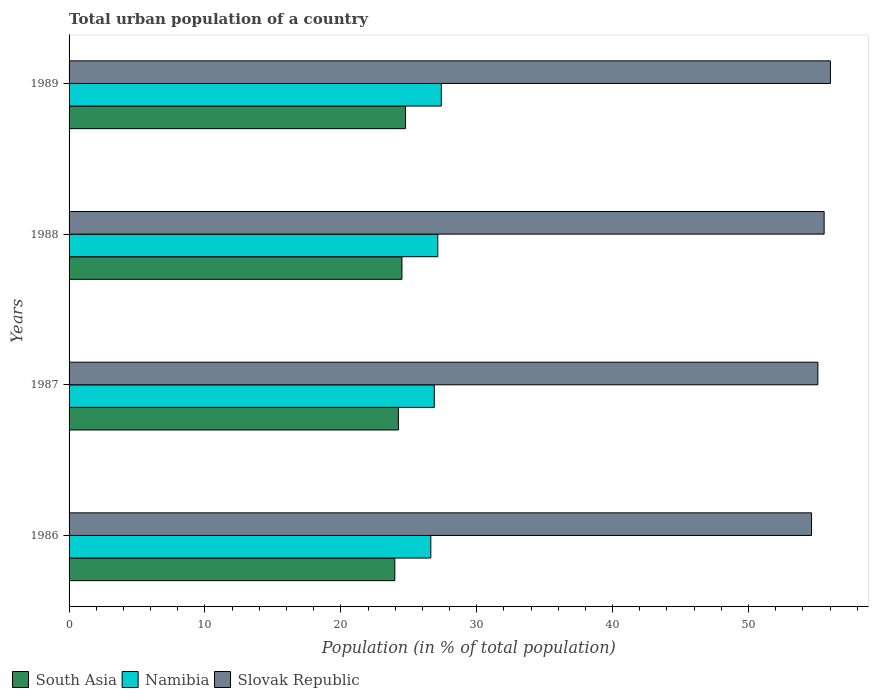How many groups of bars are there?
Keep it short and to the point. 4. Are the number of bars per tick equal to the number of legend labels?
Ensure brevity in your answer.  Yes. How many bars are there on the 1st tick from the top?
Provide a short and direct response. 3. What is the label of the 3rd group of bars from the top?
Keep it short and to the point. 1987. What is the urban population in Slovak Republic in 1986?
Offer a terse response. 54.64. Across all years, what is the maximum urban population in South Asia?
Give a very brief answer. 24.76. Across all years, what is the minimum urban population in South Asia?
Give a very brief answer. 23.97. In which year was the urban population in Namibia minimum?
Your response must be concise. 1986. What is the total urban population in Slovak Republic in the graph?
Your answer should be compact. 221.34. What is the difference between the urban population in South Asia in 1987 and that in 1989?
Keep it short and to the point. -0.53. What is the difference between the urban population in Slovak Republic in 1989 and the urban population in Namibia in 1986?
Offer a very short reply. 29.41. What is the average urban population in Slovak Republic per year?
Your answer should be very brief. 55.34. In the year 1987, what is the difference between the urban population in Slovak Republic and urban population in South Asia?
Your answer should be compact. 30.87. In how many years, is the urban population in South Asia greater than 42 %?
Provide a succinct answer. 0. What is the ratio of the urban population in Slovak Republic in 1986 to that in 1988?
Keep it short and to the point. 0.98. What is the difference between the highest and the second highest urban population in Slovak Republic?
Offer a very short reply. 0.46. What is the difference between the highest and the lowest urban population in South Asia?
Your answer should be compact. 0.79. What does the 2nd bar from the top in 1988 represents?
Your answer should be compact. Namibia. What does the 3rd bar from the bottom in 1988 represents?
Ensure brevity in your answer.  Slovak Republic. Is it the case that in every year, the sum of the urban population in South Asia and urban population in Slovak Republic is greater than the urban population in Namibia?
Give a very brief answer. Yes. How many bars are there?
Give a very brief answer. 12. Are all the bars in the graph horizontal?
Provide a short and direct response. Yes. How many years are there in the graph?
Ensure brevity in your answer.  4. Are the values on the major ticks of X-axis written in scientific E-notation?
Provide a succinct answer. No. Does the graph contain any zero values?
Keep it short and to the point. No. Does the graph contain grids?
Offer a terse response. No. Where does the legend appear in the graph?
Provide a short and direct response. Bottom left. How are the legend labels stacked?
Ensure brevity in your answer.  Horizontal. What is the title of the graph?
Your answer should be compact. Total urban population of a country. What is the label or title of the X-axis?
Offer a very short reply. Population (in % of total population). What is the Population (in % of total population) of South Asia in 1986?
Your answer should be very brief. 23.97. What is the Population (in % of total population) of Namibia in 1986?
Make the answer very short. 26.62. What is the Population (in % of total population) of Slovak Republic in 1986?
Your answer should be very brief. 54.64. What is the Population (in % of total population) of South Asia in 1987?
Your answer should be compact. 24.23. What is the Population (in % of total population) in Namibia in 1987?
Provide a short and direct response. 26.88. What is the Population (in % of total population) of Slovak Republic in 1987?
Your answer should be compact. 55.1. What is the Population (in % of total population) of South Asia in 1988?
Keep it short and to the point. 24.5. What is the Population (in % of total population) of Namibia in 1988?
Provide a short and direct response. 27.14. What is the Population (in % of total population) in Slovak Republic in 1988?
Provide a succinct answer. 55.57. What is the Population (in % of total population) in South Asia in 1989?
Offer a very short reply. 24.76. What is the Population (in % of total population) of Namibia in 1989?
Ensure brevity in your answer.  27.39. What is the Population (in % of total population) in Slovak Republic in 1989?
Your response must be concise. 56.03. Across all years, what is the maximum Population (in % of total population) of South Asia?
Offer a very short reply. 24.76. Across all years, what is the maximum Population (in % of total population) in Namibia?
Offer a terse response. 27.39. Across all years, what is the maximum Population (in % of total population) in Slovak Republic?
Your response must be concise. 56.03. Across all years, what is the minimum Population (in % of total population) of South Asia?
Give a very brief answer. 23.97. Across all years, what is the minimum Population (in % of total population) in Namibia?
Provide a short and direct response. 26.62. Across all years, what is the minimum Population (in % of total population) in Slovak Republic?
Your response must be concise. 54.64. What is the total Population (in % of total population) of South Asia in the graph?
Provide a short and direct response. 97.47. What is the total Population (in % of total population) in Namibia in the graph?
Provide a succinct answer. 108.03. What is the total Population (in % of total population) of Slovak Republic in the graph?
Provide a short and direct response. 221.34. What is the difference between the Population (in % of total population) in South Asia in 1986 and that in 1987?
Your response must be concise. -0.26. What is the difference between the Population (in % of total population) of Namibia in 1986 and that in 1987?
Your answer should be compact. -0.26. What is the difference between the Population (in % of total population) in Slovak Republic in 1986 and that in 1987?
Keep it short and to the point. -0.46. What is the difference between the Population (in % of total population) of South Asia in 1986 and that in 1988?
Your response must be concise. -0.52. What is the difference between the Population (in % of total population) of Namibia in 1986 and that in 1988?
Provide a short and direct response. -0.52. What is the difference between the Population (in % of total population) of Slovak Republic in 1986 and that in 1988?
Keep it short and to the point. -0.93. What is the difference between the Population (in % of total population) of South Asia in 1986 and that in 1989?
Give a very brief answer. -0.79. What is the difference between the Population (in % of total population) in Namibia in 1986 and that in 1989?
Give a very brief answer. -0.77. What is the difference between the Population (in % of total population) in Slovak Republic in 1986 and that in 1989?
Your answer should be compact. -1.39. What is the difference between the Population (in % of total population) in South Asia in 1987 and that in 1988?
Offer a terse response. -0.26. What is the difference between the Population (in % of total population) of Namibia in 1987 and that in 1988?
Offer a very short reply. -0.26. What is the difference between the Population (in % of total population) of Slovak Republic in 1987 and that in 1988?
Your answer should be very brief. -0.46. What is the difference between the Population (in % of total population) of South Asia in 1987 and that in 1989?
Ensure brevity in your answer.  -0.53. What is the difference between the Population (in % of total population) in Namibia in 1987 and that in 1989?
Ensure brevity in your answer.  -0.52. What is the difference between the Population (in % of total population) of Slovak Republic in 1987 and that in 1989?
Offer a very short reply. -0.93. What is the difference between the Population (in % of total population) of South Asia in 1988 and that in 1989?
Provide a short and direct response. -0.26. What is the difference between the Population (in % of total population) of Namibia in 1988 and that in 1989?
Provide a succinct answer. -0.26. What is the difference between the Population (in % of total population) of Slovak Republic in 1988 and that in 1989?
Your answer should be compact. -0.46. What is the difference between the Population (in % of total population) in South Asia in 1986 and the Population (in % of total population) in Namibia in 1987?
Make the answer very short. -2.9. What is the difference between the Population (in % of total population) in South Asia in 1986 and the Population (in % of total population) in Slovak Republic in 1987?
Make the answer very short. -31.13. What is the difference between the Population (in % of total population) of Namibia in 1986 and the Population (in % of total population) of Slovak Republic in 1987?
Offer a very short reply. -28.48. What is the difference between the Population (in % of total population) in South Asia in 1986 and the Population (in % of total population) in Namibia in 1988?
Provide a short and direct response. -3.16. What is the difference between the Population (in % of total population) in South Asia in 1986 and the Population (in % of total population) in Slovak Republic in 1988?
Offer a terse response. -31.59. What is the difference between the Population (in % of total population) of Namibia in 1986 and the Population (in % of total population) of Slovak Republic in 1988?
Offer a terse response. -28.95. What is the difference between the Population (in % of total population) of South Asia in 1986 and the Population (in % of total population) of Namibia in 1989?
Give a very brief answer. -3.42. What is the difference between the Population (in % of total population) of South Asia in 1986 and the Population (in % of total population) of Slovak Republic in 1989?
Your answer should be compact. -32.06. What is the difference between the Population (in % of total population) in Namibia in 1986 and the Population (in % of total population) in Slovak Republic in 1989?
Provide a succinct answer. -29.41. What is the difference between the Population (in % of total population) in South Asia in 1987 and the Population (in % of total population) in Namibia in 1988?
Provide a succinct answer. -2.9. What is the difference between the Population (in % of total population) of South Asia in 1987 and the Population (in % of total population) of Slovak Republic in 1988?
Your answer should be very brief. -31.33. What is the difference between the Population (in % of total population) in Namibia in 1987 and the Population (in % of total population) in Slovak Republic in 1988?
Keep it short and to the point. -28.69. What is the difference between the Population (in % of total population) in South Asia in 1987 and the Population (in % of total population) in Namibia in 1989?
Keep it short and to the point. -3.16. What is the difference between the Population (in % of total population) in South Asia in 1987 and the Population (in % of total population) in Slovak Republic in 1989?
Your response must be concise. -31.8. What is the difference between the Population (in % of total population) in Namibia in 1987 and the Population (in % of total population) in Slovak Republic in 1989?
Ensure brevity in your answer.  -29.15. What is the difference between the Population (in % of total population) of South Asia in 1988 and the Population (in % of total population) of Namibia in 1989?
Your response must be concise. -2.9. What is the difference between the Population (in % of total population) in South Asia in 1988 and the Population (in % of total population) in Slovak Republic in 1989?
Offer a very short reply. -31.53. What is the difference between the Population (in % of total population) in Namibia in 1988 and the Population (in % of total population) in Slovak Republic in 1989?
Your response must be concise. -28.89. What is the average Population (in % of total population) of South Asia per year?
Give a very brief answer. 24.37. What is the average Population (in % of total population) in Namibia per year?
Ensure brevity in your answer.  27.01. What is the average Population (in % of total population) in Slovak Republic per year?
Your response must be concise. 55.34. In the year 1986, what is the difference between the Population (in % of total population) of South Asia and Population (in % of total population) of Namibia?
Give a very brief answer. -2.65. In the year 1986, what is the difference between the Population (in % of total population) of South Asia and Population (in % of total population) of Slovak Republic?
Offer a terse response. -30.67. In the year 1986, what is the difference between the Population (in % of total population) of Namibia and Population (in % of total population) of Slovak Republic?
Make the answer very short. -28.02. In the year 1987, what is the difference between the Population (in % of total population) in South Asia and Population (in % of total population) in Namibia?
Offer a terse response. -2.64. In the year 1987, what is the difference between the Population (in % of total population) in South Asia and Population (in % of total population) in Slovak Republic?
Provide a short and direct response. -30.87. In the year 1987, what is the difference between the Population (in % of total population) of Namibia and Population (in % of total population) of Slovak Republic?
Give a very brief answer. -28.23. In the year 1988, what is the difference between the Population (in % of total population) in South Asia and Population (in % of total population) in Namibia?
Provide a short and direct response. -2.64. In the year 1988, what is the difference between the Population (in % of total population) of South Asia and Population (in % of total population) of Slovak Republic?
Make the answer very short. -31.07. In the year 1988, what is the difference between the Population (in % of total population) in Namibia and Population (in % of total population) in Slovak Republic?
Your response must be concise. -28.43. In the year 1989, what is the difference between the Population (in % of total population) in South Asia and Population (in % of total population) in Namibia?
Keep it short and to the point. -2.63. In the year 1989, what is the difference between the Population (in % of total population) of South Asia and Population (in % of total population) of Slovak Republic?
Offer a very short reply. -31.27. In the year 1989, what is the difference between the Population (in % of total population) in Namibia and Population (in % of total population) in Slovak Republic?
Keep it short and to the point. -28.64. What is the ratio of the Population (in % of total population) of South Asia in 1986 to that in 1987?
Offer a very short reply. 0.99. What is the ratio of the Population (in % of total population) in Namibia in 1986 to that in 1987?
Your answer should be very brief. 0.99. What is the ratio of the Population (in % of total population) in South Asia in 1986 to that in 1988?
Your answer should be compact. 0.98. What is the ratio of the Population (in % of total population) of Slovak Republic in 1986 to that in 1988?
Offer a terse response. 0.98. What is the ratio of the Population (in % of total population) in South Asia in 1986 to that in 1989?
Provide a succinct answer. 0.97. What is the ratio of the Population (in % of total population) of Namibia in 1986 to that in 1989?
Give a very brief answer. 0.97. What is the ratio of the Population (in % of total population) of Slovak Republic in 1986 to that in 1989?
Provide a short and direct response. 0.98. What is the ratio of the Population (in % of total population) in South Asia in 1987 to that in 1988?
Keep it short and to the point. 0.99. What is the ratio of the Population (in % of total population) in Slovak Republic in 1987 to that in 1988?
Your answer should be very brief. 0.99. What is the ratio of the Population (in % of total population) in South Asia in 1987 to that in 1989?
Your answer should be very brief. 0.98. What is the ratio of the Population (in % of total population) in Namibia in 1987 to that in 1989?
Keep it short and to the point. 0.98. What is the ratio of the Population (in % of total population) in Slovak Republic in 1987 to that in 1989?
Give a very brief answer. 0.98. What is the ratio of the Population (in % of total population) of South Asia in 1988 to that in 1989?
Offer a very short reply. 0.99. What is the ratio of the Population (in % of total population) in Slovak Republic in 1988 to that in 1989?
Provide a succinct answer. 0.99. What is the difference between the highest and the second highest Population (in % of total population) in South Asia?
Keep it short and to the point. 0.26. What is the difference between the highest and the second highest Population (in % of total population) of Namibia?
Your answer should be very brief. 0.26. What is the difference between the highest and the second highest Population (in % of total population) in Slovak Republic?
Your answer should be very brief. 0.46. What is the difference between the highest and the lowest Population (in % of total population) in South Asia?
Your answer should be very brief. 0.79. What is the difference between the highest and the lowest Population (in % of total population) in Namibia?
Provide a succinct answer. 0.77. What is the difference between the highest and the lowest Population (in % of total population) in Slovak Republic?
Your answer should be compact. 1.39. 